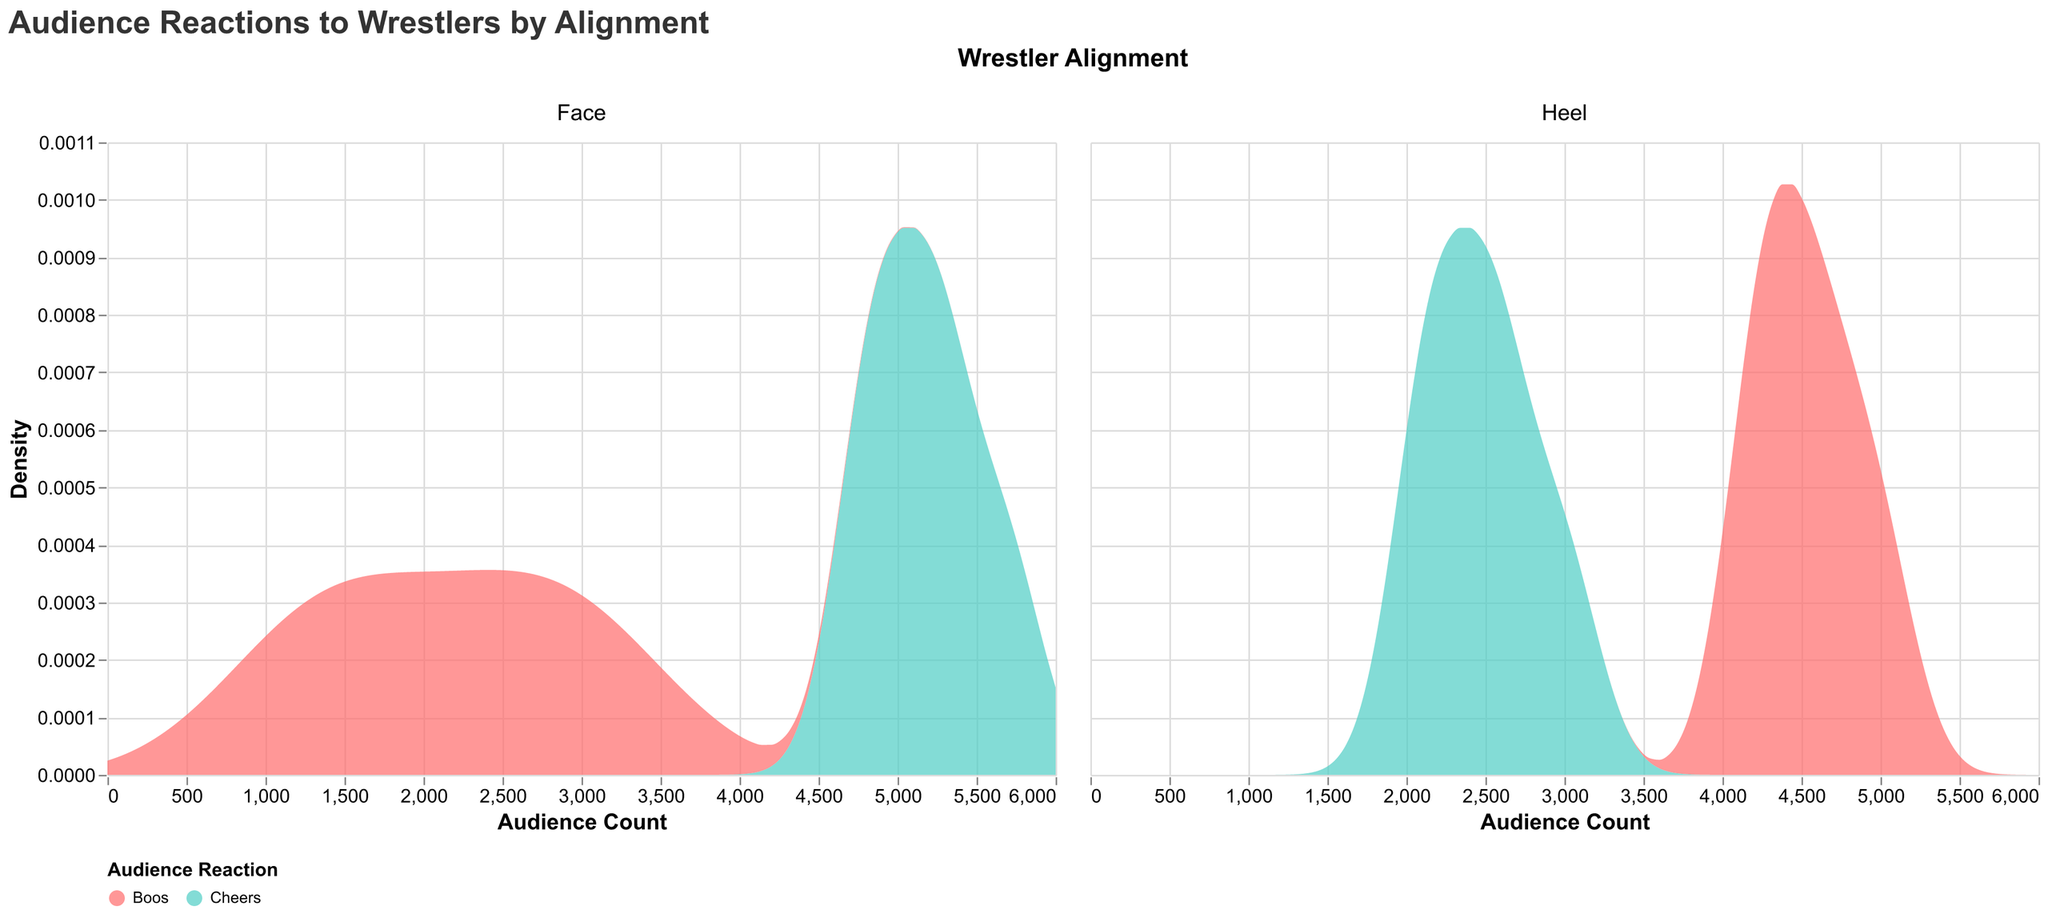What is the title of the plot? The title of the plot is prominently displayed at the top and reads "Audience Reactions to Wrestlers by Alignment"
Answer: Audience Reactions to Wrestlers by Alignment What color represents "Cheers" in the plot? The color legend shows that "Cheers" is represented by a turquoise color (#4ECDC4)
Answer: Turquoise Which alignment has the highest density of cheers? By comparing the densities in the "Face" and "Heel" columns, one can observe that "Face" wrestlers have a higher density of cheers overall compared to "Heel" wrestlers
Answer: Face Among face wrestlers, who received the highest total count of reactions (both cheers and boos)? Adding the counts of cheers and boos for each face wrestler: 
John Cena: 5200 + 2800 = 8000,
Roman Reigns: 4900 + 3100 = 8000,
The Undertaker: 5700 + 1400 = 7100,
Becky Lynch: 5300 + 1300 = 6600,
Seth Rollins: 4800 + 2200 = 7000. John Cena and Roman Reigns both have the highest total count of 8000
Answer: John Cena and Roman Reigns Which heel wrestler receives more cheers, Brock Lesnar or Sasha Banks? According to the data, Brock Lesnar received 2200 cheers while Sasha Banks received 2600 cheers
Answer: Sasha Banks Compare the density of boos for heels and faces; which group has a wider spread? By visually comparing the boos density plots for both alignments, "Heel" wrestlers show a wider spread of boos indicating a higher range of boos counts
Answer: Heel What is the range of audience counts considered in this plot? The x-axis of the plot indicates that the range of audience counts goes from 0 to 6000
Answer: 0 to 6000 Which wrestler alignment corresponds to the higher density of boos close to the maximum audience count? Comparing the density plots, "Heel" wrestlers show a higher density near the maximum audience count for boos
Answer: Heel What is the primary difference between face and heel wrestlers in terms of audience reaction density? Faces generally have higher densities for cheers, while heels have higher densities for boos. This can be inferred from the density plots where the peaks for cheers are higher for faces and the peaks for boos are higher for heels
Answer: Faces have higher cheers; Heels have higher boos How would you describe the audience reaction pattern for The Undertaker? The Undertaker, who is a face wrestler, shows a high density of cheers around the upper audience count range (close to 5700) but a very low density of boos (1400), indicating strong positive reception
Answer: High cheers, low boos 